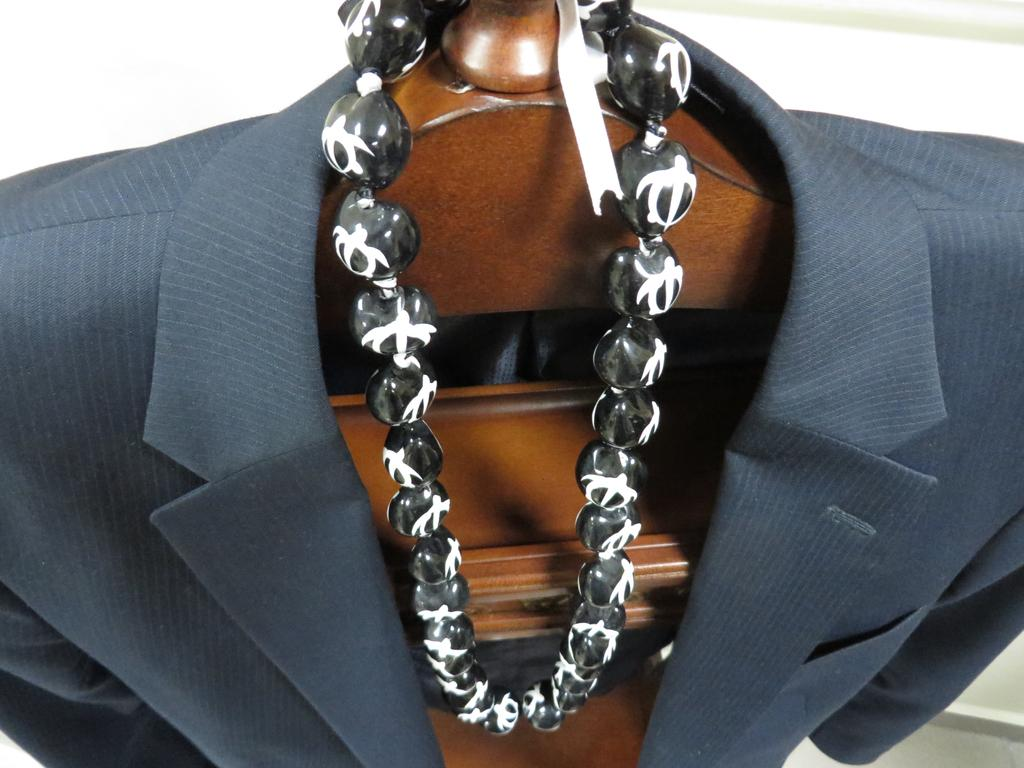What material is present in the image? There is wood in the image. What is placed on the wood in the image? There is a suit on the wood. What other object can be seen on the wood? There is a chain on the wood. What color is the background of the image? The background of the image is white. How many cups are visible on the wood in the image? There are no cups visible on the wood in the image. How many legs are visible on the wood in the image? There are no legs visible on the wood in the image. 